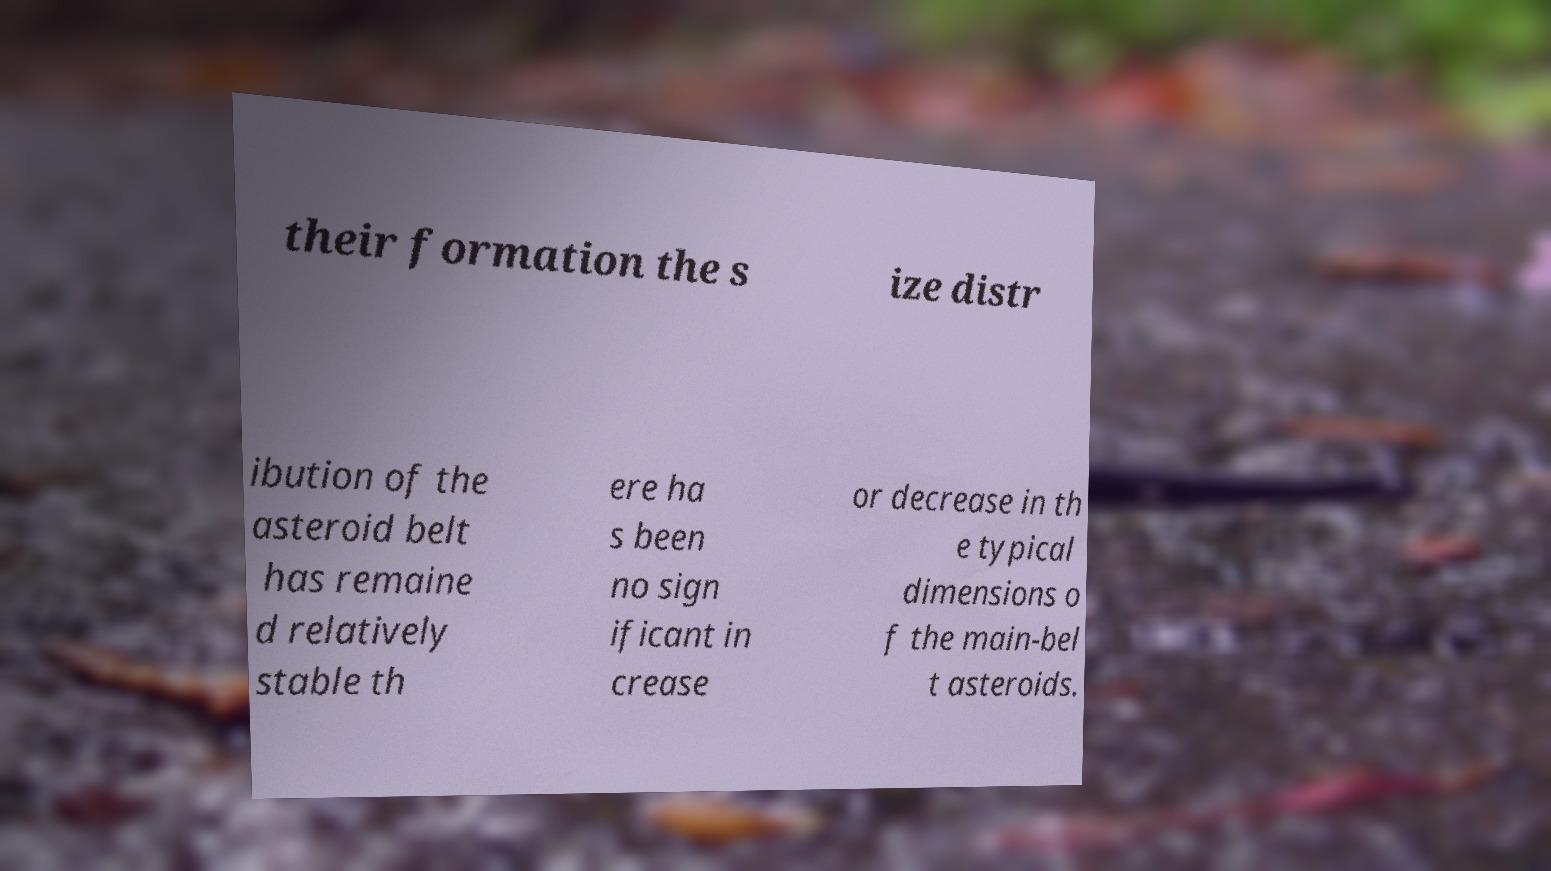Can you read and provide the text displayed in the image?This photo seems to have some interesting text. Can you extract and type it out for me? their formation the s ize distr ibution of the asteroid belt has remaine d relatively stable th ere ha s been no sign ificant in crease or decrease in th e typical dimensions o f the main-bel t asteroids. 